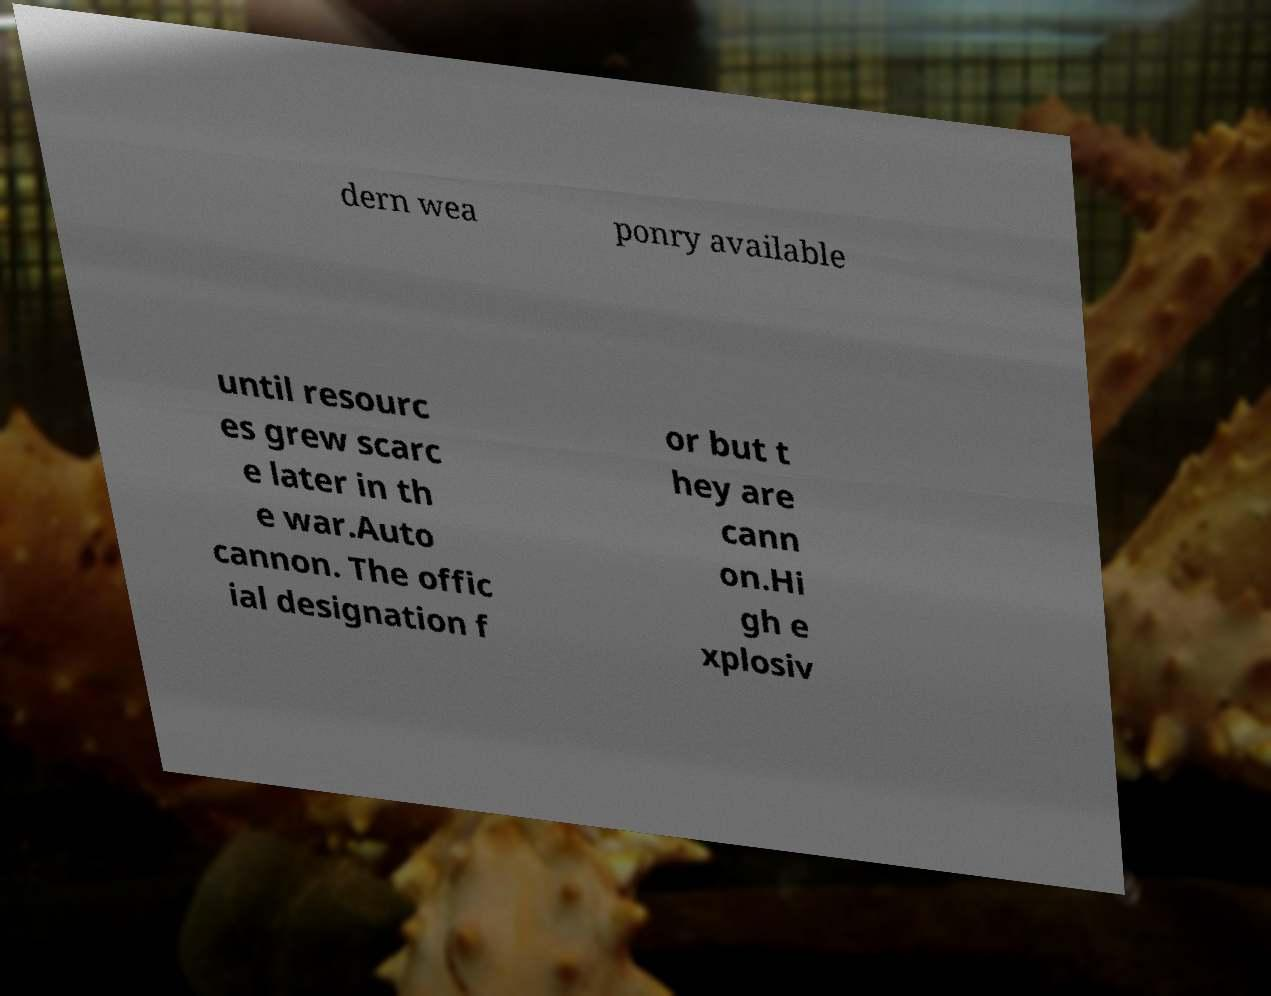Can you read and provide the text displayed in the image?This photo seems to have some interesting text. Can you extract and type it out for me? dern wea ponry available until resourc es grew scarc e later in th e war.Auto cannon. The offic ial designation f or but t hey are cann on.Hi gh e xplosiv 